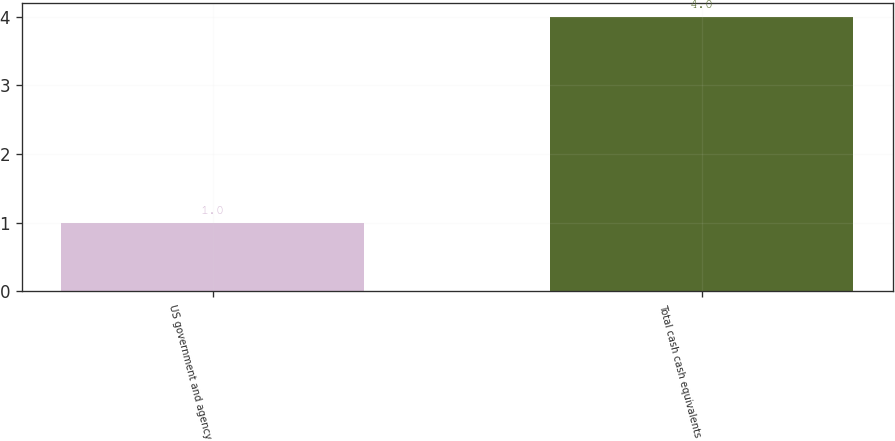<chart> <loc_0><loc_0><loc_500><loc_500><bar_chart><fcel>US government and agency<fcel>Total cash cash equivalents<nl><fcel>1<fcel>4<nl></chart> 